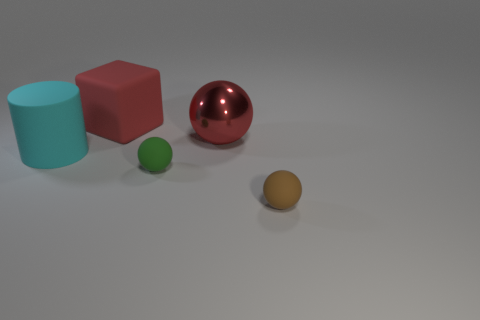Are there any other things that are the same color as the big metal ball?
Ensure brevity in your answer.  Yes. There is a matte object that is right of the big metal ball; does it have the same size as the rubber thing on the left side of the big red rubber block?
Ensure brevity in your answer.  No. Is the color of the big metal ball the same as the block?
Offer a terse response. Yes. What number of matte things have the same color as the big shiny ball?
Ensure brevity in your answer.  1. How big is the ball that is on the right side of the tiny green matte object and to the left of the brown object?
Provide a succinct answer. Large. Is the ball that is behind the big cyan matte object made of the same material as the large thing on the left side of the big rubber block?
Your answer should be compact. No. There is a brown thing that is the same size as the green matte object; what shape is it?
Give a very brief answer. Sphere. Are there fewer brown balls than small brown metal cylinders?
Give a very brief answer. No. There is a small rubber object that is on the left side of the brown ball; are there any green objects to the right of it?
Your answer should be very brief. No. Is there a tiny object right of the small matte sphere to the left of the red thing that is in front of the large red block?
Your answer should be compact. Yes. 